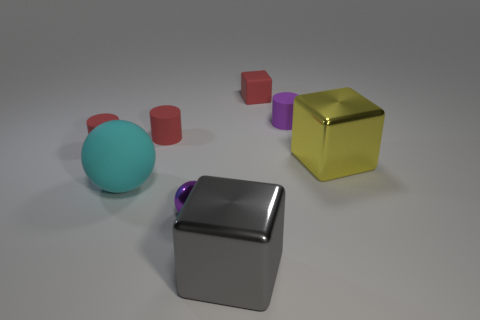Subtract all green spheres. How many red cylinders are left? 2 Subtract all small cubes. How many cubes are left? 2 Subtract 1 cylinders. How many cylinders are left? 2 Add 1 red blocks. How many objects exist? 9 Subtract all green cubes. Subtract all purple balls. How many cubes are left? 3 Subtract all blocks. How many objects are left? 5 Subtract 0 red balls. How many objects are left? 8 Subtract all yellow objects. Subtract all large gray metal cubes. How many objects are left? 6 Add 2 metallic spheres. How many metallic spheres are left? 3 Add 5 gray metallic things. How many gray metallic things exist? 6 